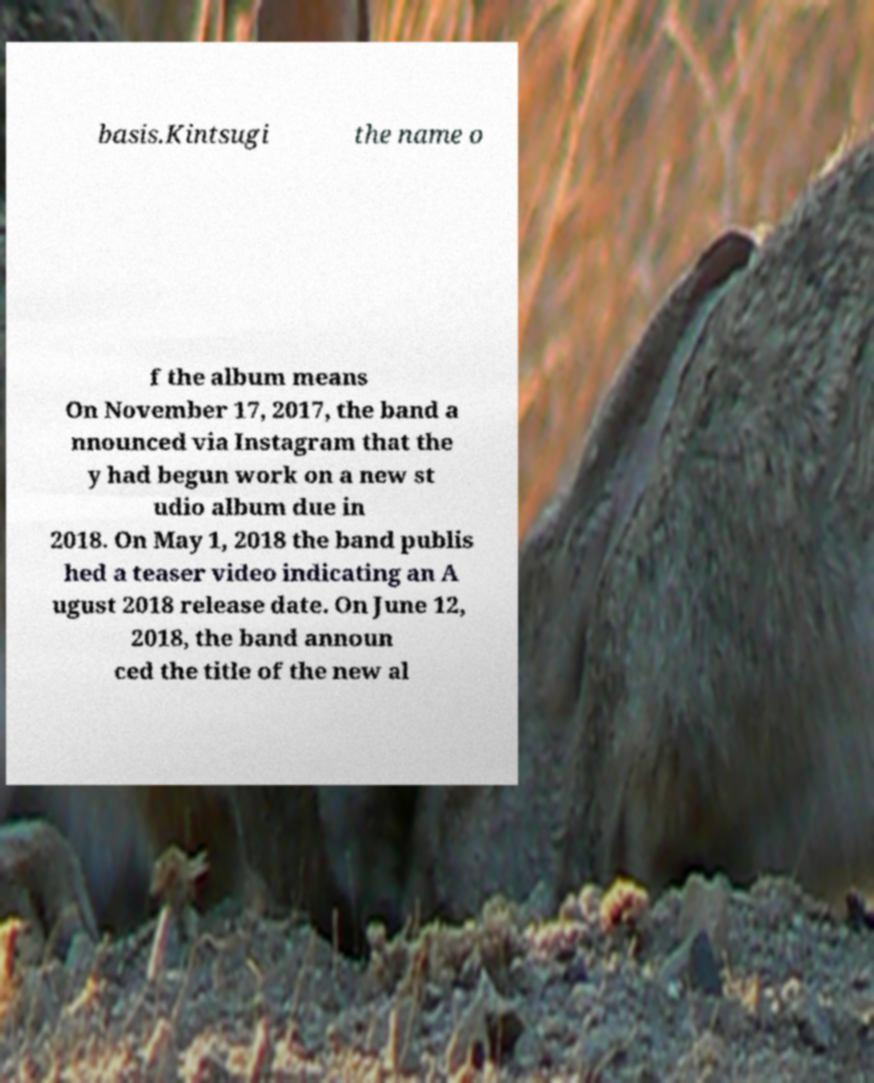I need the written content from this picture converted into text. Can you do that? basis.Kintsugi the name o f the album means On November 17, 2017, the band a nnounced via Instagram that the y had begun work on a new st udio album due in 2018. On May 1, 2018 the band publis hed a teaser video indicating an A ugust 2018 release date. On June 12, 2018, the band announ ced the title of the new al 